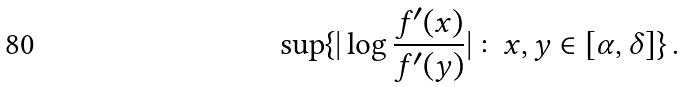Convert formula to latex. <formula><loc_0><loc_0><loc_500><loc_500>\sup \{ | \log \frac { f ^ { \prime } ( x ) } { f ^ { \prime } ( y ) } | \colon x , y \in [ \alpha , \delta ] \} \, .</formula> 